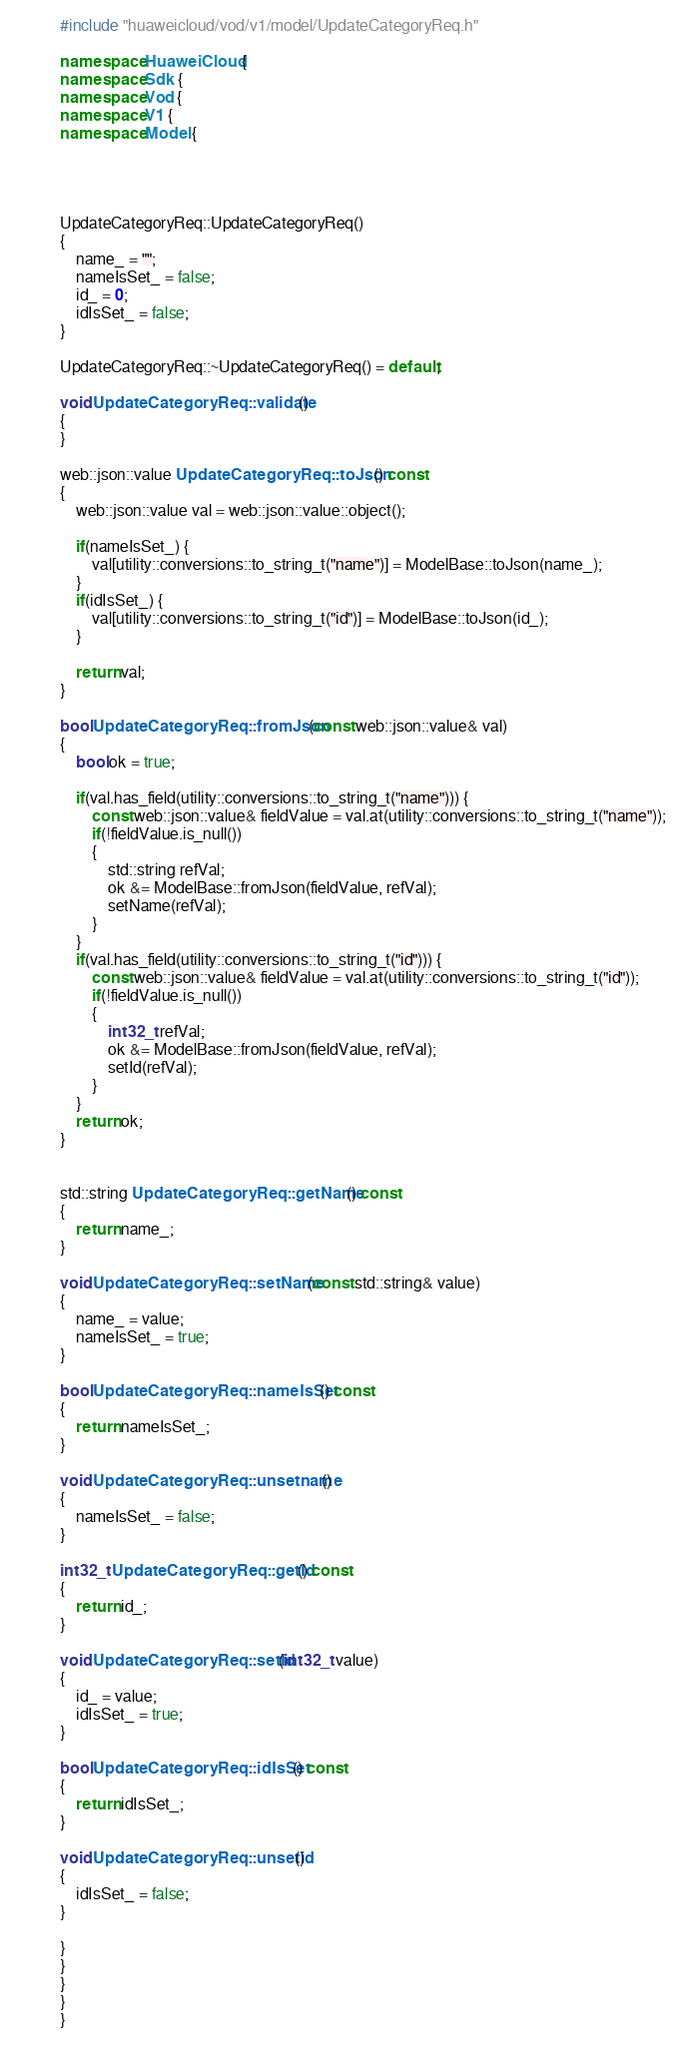Convert code to text. <code><loc_0><loc_0><loc_500><loc_500><_C++_>

#include "huaweicloud/vod/v1/model/UpdateCategoryReq.h"

namespace HuaweiCloud {
namespace Sdk {
namespace Vod {
namespace V1 {
namespace Model {




UpdateCategoryReq::UpdateCategoryReq()
{
    name_ = "";
    nameIsSet_ = false;
    id_ = 0;
    idIsSet_ = false;
}

UpdateCategoryReq::~UpdateCategoryReq() = default;

void UpdateCategoryReq::validate()
{
}

web::json::value UpdateCategoryReq::toJson() const
{
    web::json::value val = web::json::value::object();

    if(nameIsSet_) {
        val[utility::conversions::to_string_t("name")] = ModelBase::toJson(name_);
    }
    if(idIsSet_) {
        val[utility::conversions::to_string_t("id")] = ModelBase::toJson(id_);
    }

    return val;
}

bool UpdateCategoryReq::fromJson(const web::json::value& val)
{
    bool ok = true;
    
    if(val.has_field(utility::conversions::to_string_t("name"))) {
        const web::json::value& fieldValue = val.at(utility::conversions::to_string_t("name"));
        if(!fieldValue.is_null())
        {
            std::string refVal;
            ok &= ModelBase::fromJson(fieldValue, refVal);
            setName(refVal);
        }
    }
    if(val.has_field(utility::conversions::to_string_t("id"))) {
        const web::json::value& fieldValue = val.at(utility::conversions::to_string_t("id"));
        if(!fieldValue.is_null())
        {
            int32_t refVal;
            ok &= ModelBase::fromJson(fieldValue, refVal);
            setId(refVal);
        }
    }
    return ok;
}


std::string UpdateCategoryReq::getName() const
{
    return name_;
}

void UpdateCategoryReq::setName(const std::string& value)
{
    name_ = value;
    nameIsSet_ = true;
}

bool UpdateCategoryReq::nameIsSet() const
{
    return nameIsSet_;
}

void UpdateCategoryReq::unsetname()
{
    nameIsSet_ = false;
}

int32_t UpdateCategoryReq::getId() const
{
    return id_;
}

void UpdateCategoryReq::setId(int32_t value)
{
    id_ = value;
    idIsSet_ = true;
}

bool UpdateCategoryReq::idIsSet() const
{
    return idIsSet_;
}

void UpdateCategoryReq::unsetid()
{
    idIsSet_ = false;
}

}
}
}
}
}


</code> 